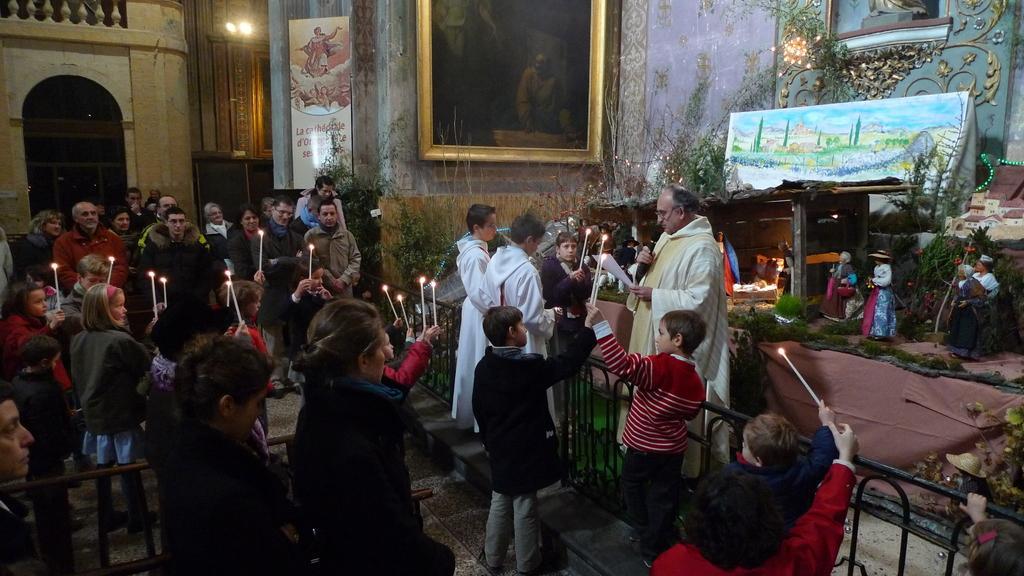How would you summarize this image in a sentence or two? In the center of the image we can see people holding candles in their hands and standing. In the background of the image there is a wall on which there are photo frames. There is a window. There is a metal fencing. To the right side of the image there are statues. 